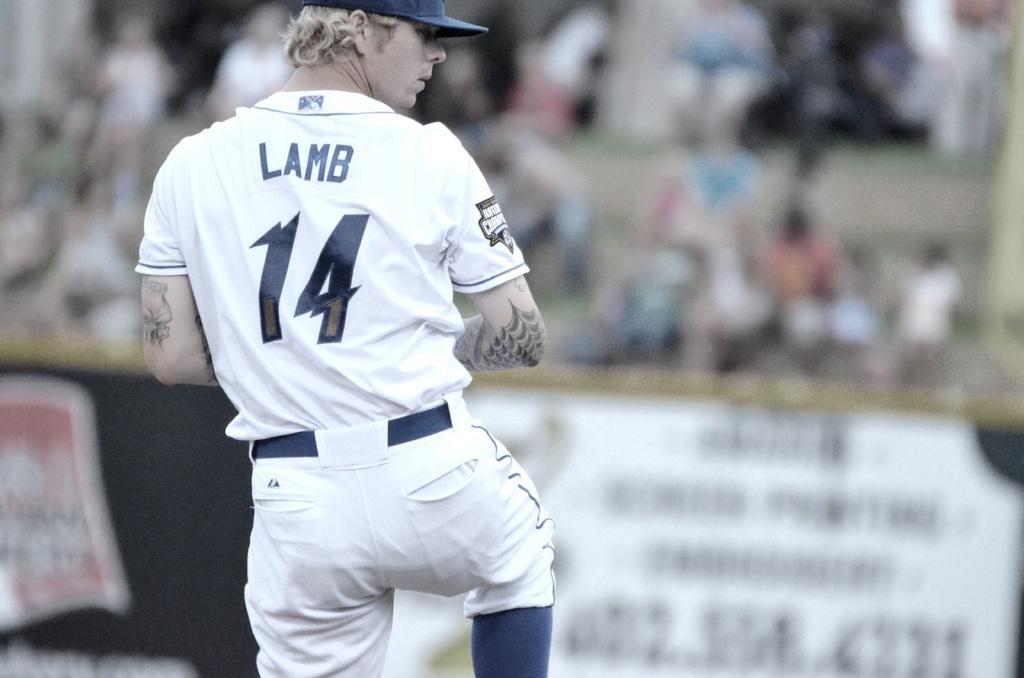<image>
Create a compact narrative representing the image presented. A baseball player who's wearing number 14 and is named Lamb prepares to throw a pitch. 